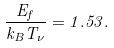Convert formula to latex. <formula><loc_0><loc_0><loc_500><loc_500>\frac { E _ { f } } { k _ { B } T _ { \nu } } = 1 . 5 3 .</formula> 